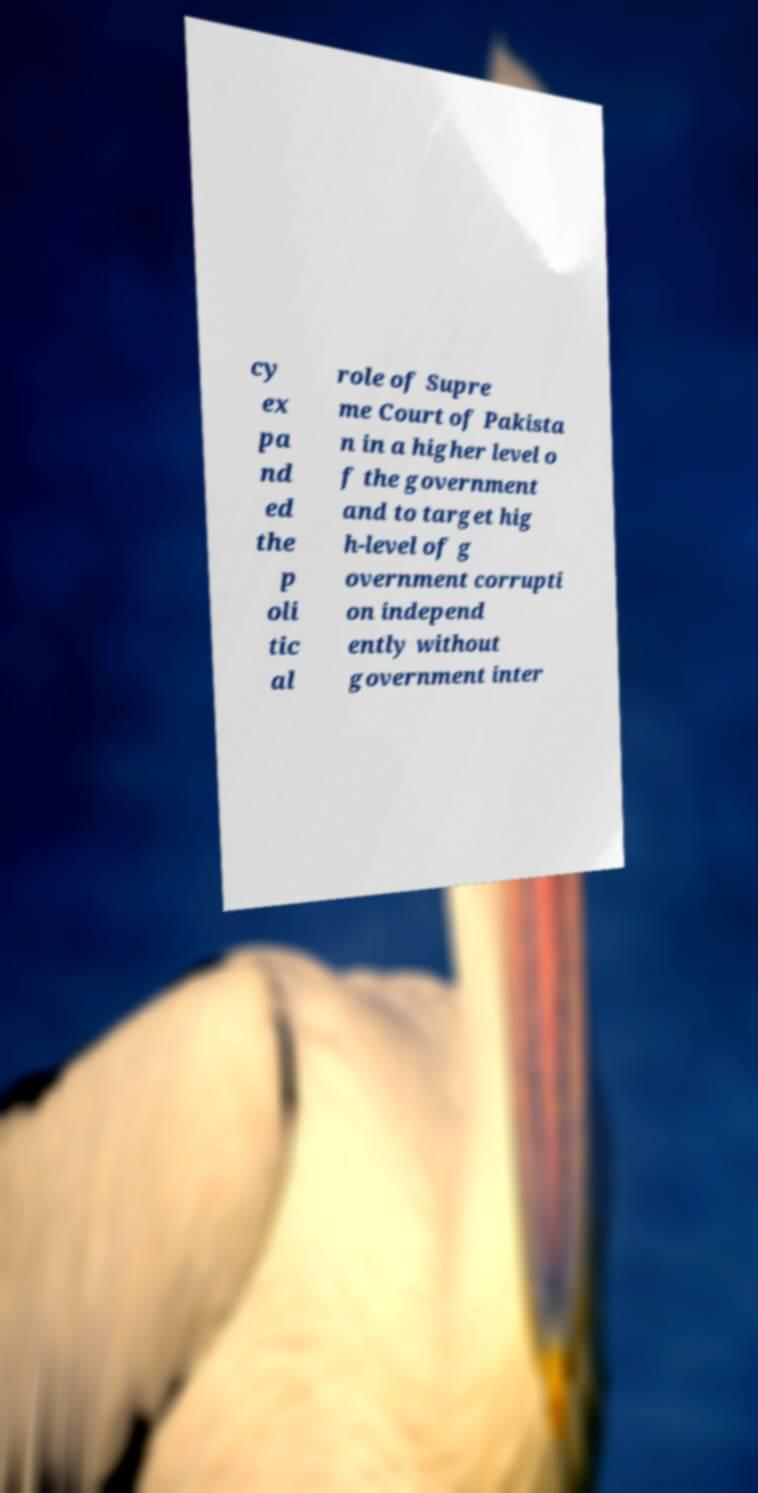Can you read and provide the text displayed in the image?This photo seems to have some interesting text. Can you extract and type it out for me? cy ex pa nd ed the p oli tic al role of Supre me Court of Pakista n in a higher level o f the government and to target hig h-level of g overnment corrupti on independ ently without government inter 